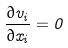<formula> <loc_0><loc_0><loc_500><loc_500>\frac { \partial v _ { i } } { \partial x _ { i } } = 0</formula> 